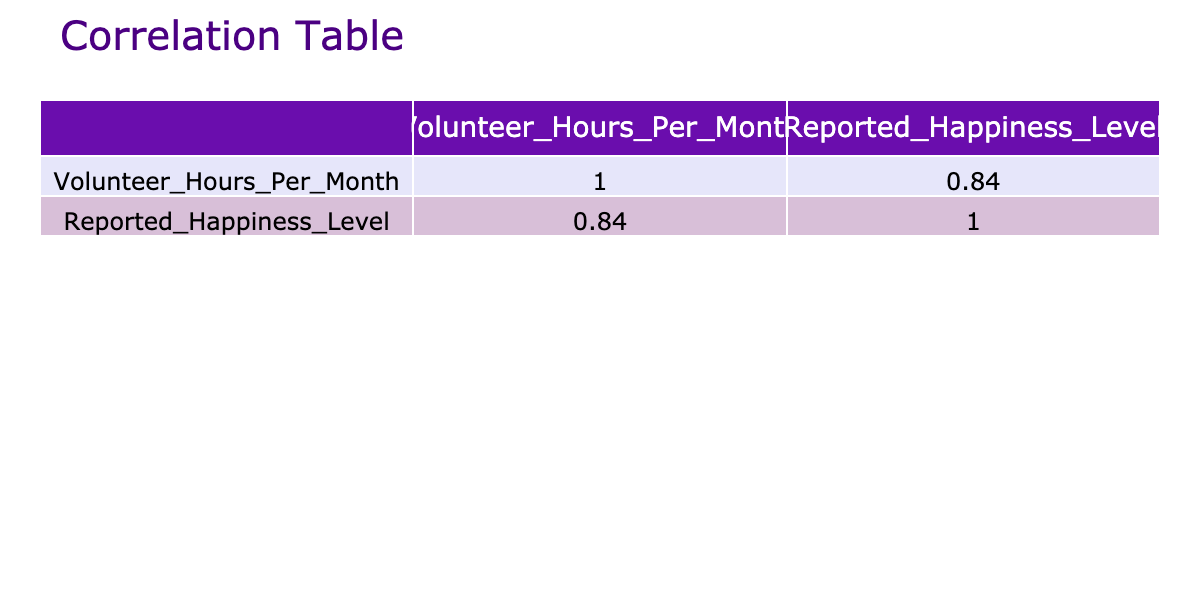What is the reported happiness level in Fairview? The table shows that Fairview has a reported happiness level of 10.
Answer: 10 How many volunteer hours does Cedarville have? According to the table, Cedarville has 40 volunteer hours per month.
Answer: 40 What is the difference in reported happiness level between Lakewood and Springfield? Lakewood has a reported happiness level of 9, while Springfield has 7. The difference is 9 - 7 = 2.
Answer: 2 Is the reported happiness level higher in communities with more than 20 volunteer hours? The communities with more than 20 volunteer hours (Maplewood, Fairview, Cedarville, Lakewood) have reported happiness levels of 9, 10, 8, and 9 respectively, which are all higher than 6 and 7 of those with less than 20 hours.
Answer: Yes What is the average reported happiness level of the communities listed? To find the average, sum the reported happiness levels (7 + 8 + 6 + 9 + 5 + 10 + 8 + 6 + 9 + 6 = 66) and divide by the number of communities (10). The average is 66 / 10 = 6.6.
Answer: 6.6 Which community reported the highest happiness level? The table indicates that Fairview reported the highest happiness level of 10.
Answer: Fairview How many communities have reported happiness levels equal to or greater than 8? The communities with reported happiness levels of 8 or more are Riverdale, Maplewood, Fairview, and Lakewood. This totals 4 communities.
Answer: 4 What is the total number of volunteer hours contributed by all communities? By summing the volunteer hours (15 + 20 + 10 + 25 + 5 + 30 + 40 + 12 + 35 + 8 =  200), the total number of volunteer hours is 200.
Answer: 200 Are communities with fewer than 10 volunteer hours generally less happy? Communities with fewer than 10 volunteer hours (Sunnyvale, Greenville, and Elm Grove) have reported happiness levels of 6, 5, and 6 respectively, which indicates they are less happy compared to other communities.
Answer: Yes 